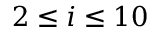Convert formula to latex. <formula><loc_0><loc_0><loc_500><loc_500>2 \leq i \leq 1 0</formula> 